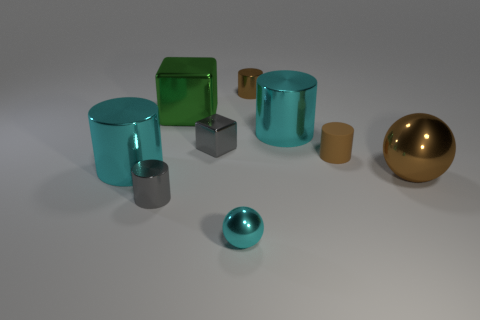Is there any other thing of the same color as the tiny shiny cube?
Your response must be concise. Yes. Is the number of small cyan spheres that are on the right side of the tiny cyan object the same as the number of cyan metal cylinders that are behind the green thing?
Ensure brevity in your answer.  Yes. Is the number of cyan metal cylinders to the left of the tiny gray block greater than the number of tiny cyan rubber cylinders?
Keep it short and to the point. Yes. How many objects are big cyan cylinders to the right of the tiny sphere or large brown rubber balls?
Ensure brevity in your answer.  1. What number of small spheres have the same material as the green thing?
Ensure brevity in your answer.  1. What shape is the rubber thing that is the same color as the large metal ball?
Your answer should be compact. Cylinder. Is there a gray metal object that has the same shape as the large brown metallic thing?
Your answer should be compact. No. The brown metallic thing that is the same size as the green object is what shape?
Offer a terse response. Sphere. There is a large metallic sphere; is its color the same as the shiny cylinder behind the big shiny cube?
Make the answer very short. Yes. How many blocks are behind the large cyan cylinder behind the gray metal block?
Your answer should be compact. 1. 